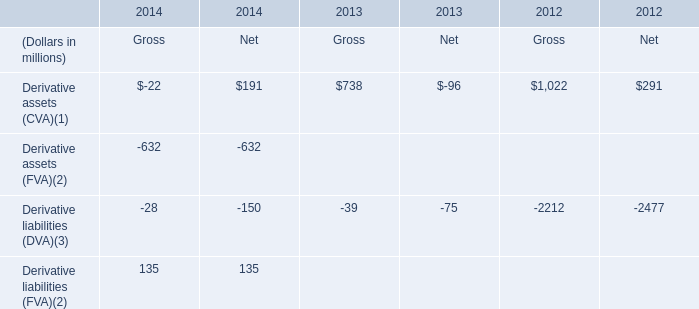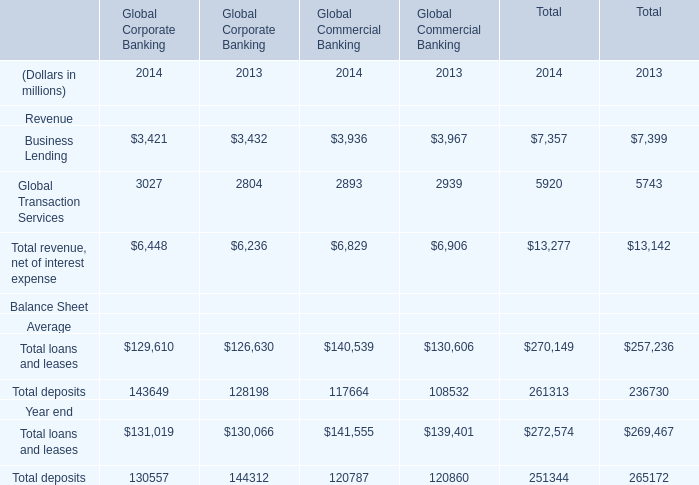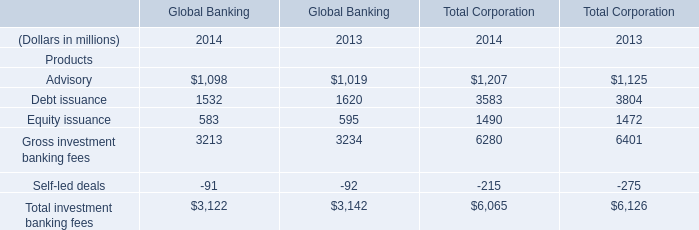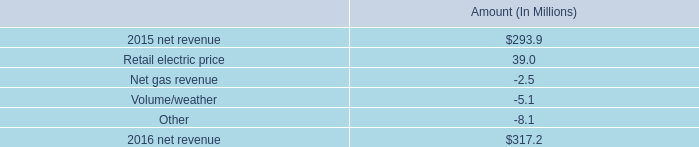What is the sum of Equity issuance of Global Banking in 2013 and Derivative assets (CVA) of Gross in 2012? (in million) 
Computations: (595 + 1022)
Answer: 1617.0. 